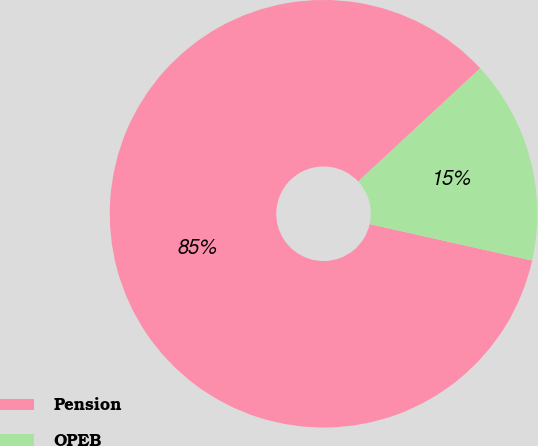<chart> <loc_0><loc_0><loc_500><loc_500><pie_chart><fcel>Pension<fcel>OPEB<nl><fcel>84.58%<fcel>15.42%<nl></chart> 